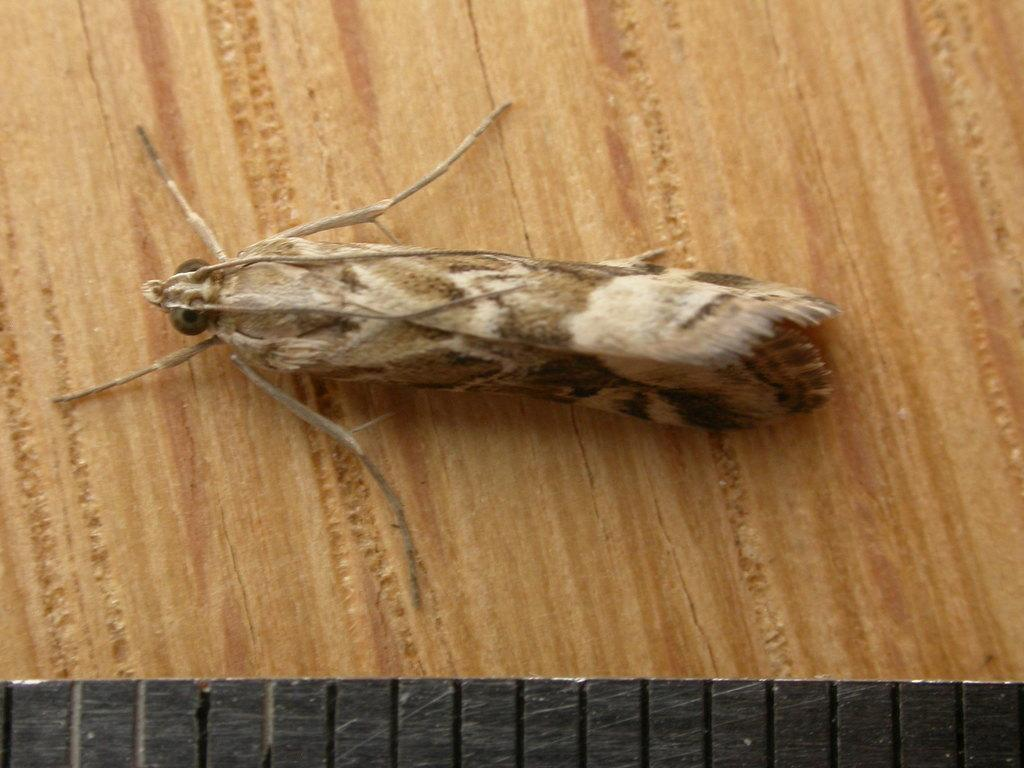What type of creature is in the image? There is an insect in the image. What color is the insect? The insect is brown in color. Where is the insect located in the image? The insect is on a table. What role does the porter play in the image? There is no porter present in the image; it only features an insect on a table. What type of cast is visible on the insect in the image? There is no cast on the insect in the image; it is a regular insect without any visible medical devices. 